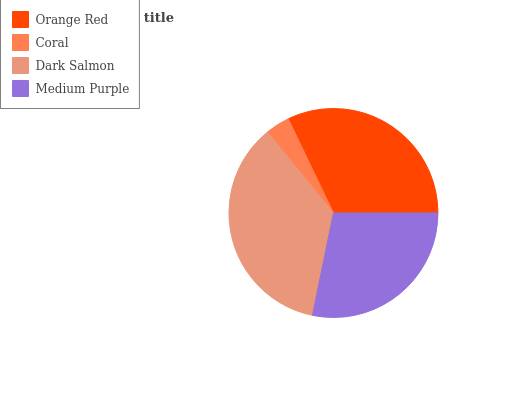Is Coral the minimum?
Answer yes or no. Yes. Is Dark Salmon the maximum?
Answer yes or no. Yes. Is Dark Salmon the minimum?
Answer yes or no. No. Is Coral the maximum?
Answer yes or no. No. Is Dark Salmon greater than Coral?
Answer yes or no. Yes. Is Coral less than Dark Salmon?
Answer yes or no. Yes. Is Coral greater than Dark Salmon?
Answer yes or no. No. Is Dark Salmon less than Coral?
Answer yes or no. No. Is Orange Red the high median?
Answer yes or no. Yes. Is Medium Purple the low median?
Answer yes or no. Yes. Is Coral the high median?
Answer yes or no. No. Is Dark Salmon the low median?
Answer yes or no. No. 